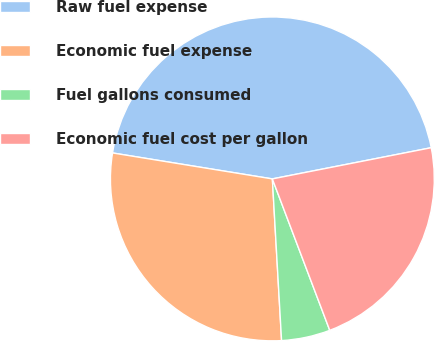<chart> <loc_0><loc_0><loc_500><loc_500><pie_chart><fcel>Raw fuel expense<fcel>Economic fuel expense<fcel>Fuel gallons consumed<fcel>Economic fuel cost per gallon<nl><fcel>44.35%<fcel>28.47%<fcel>4.86%<fcel>22.32%<nl></chart> 